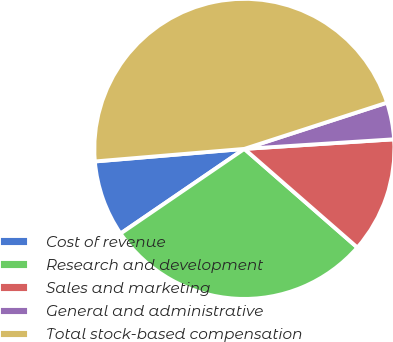Convert chart. <chart><loc_0><loc_0><loc_500><loc_500><pie_chart><fcel>Cost of revenue<fcel>Research and development<fcel>Sales and marketing<fcel>General and administrative<fcel>Total stock-based compensation<nl><fcel>8.21%<fcel>29.03%<fcel>12.44%<fcel>3.97%<fcel>46.34%<nl></chart> 